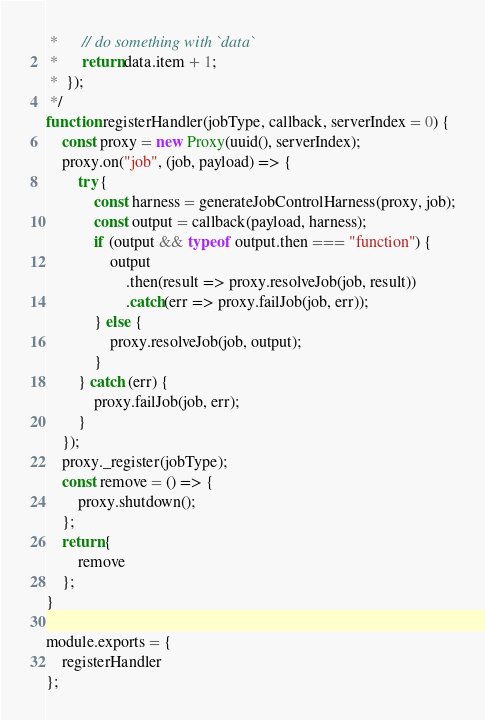<code> <loc_0><loc_0><loc_500><loc_500><_JavaScript_> *      // do something with `data`
 *      return data.item + 1;
 *  });
 */
function registerHandler(jobType, callback, serverIndex = 0) {
    const proxy = new Proxy(uuid(), serverIndex);
    proxy.on("job", (job, payload) => {
        try {
            const harness = generateJobControlHarness(proxy, job);
            const output = callback(payload, harness);
            if (output && typeof output.then === "function") {
                output
                    .then(result => proxy.resolveJob(job, result))
                    .catch(err => proxy.failJob(job, err));
            } else {
                proxy.resolveJob(job, output);
            }
        } catch (err) {
            proxy.failJob(job, err);
        }
    });
    proxy._register(jobType);
    const remove = () => {
        proxy.shutdown();
    };
    return {
        remove
    };
}

module.exports = {
    registerHandler
};
</code> 